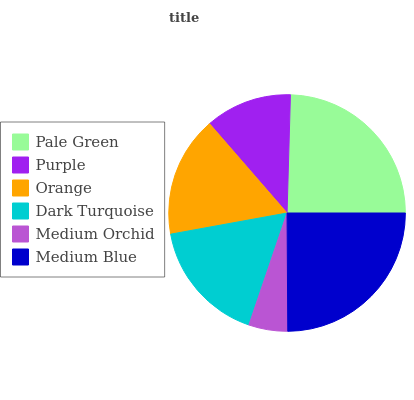Is Medium Orchid the minimum?
Answer yes or no. Yes. Is Medium Blue the maximum?
Answer yes or no. Yes. Is Purple the minimum?
Answer yes or no. No. Is Purple the maximum?
Answer yes or no. No. Is Pale Green greater than Purple?
Answer yes or no. Yes. Is Purple less than Pale Green?
Answer yes or no. Yes. Is Purple greater than Pale Green?
Answer yes or no. No. Is Pale Green less than Purple?
Answer yes or no. No. Is Dark Turquoise the high median?
Answer yes or no. Yes. Is Orange the low median?
Answer yes or no. Yes. Is Medium Blue the high median?
Answer yes or no. No. Is Medium Blue the low median?
Answer yes or no. No. 